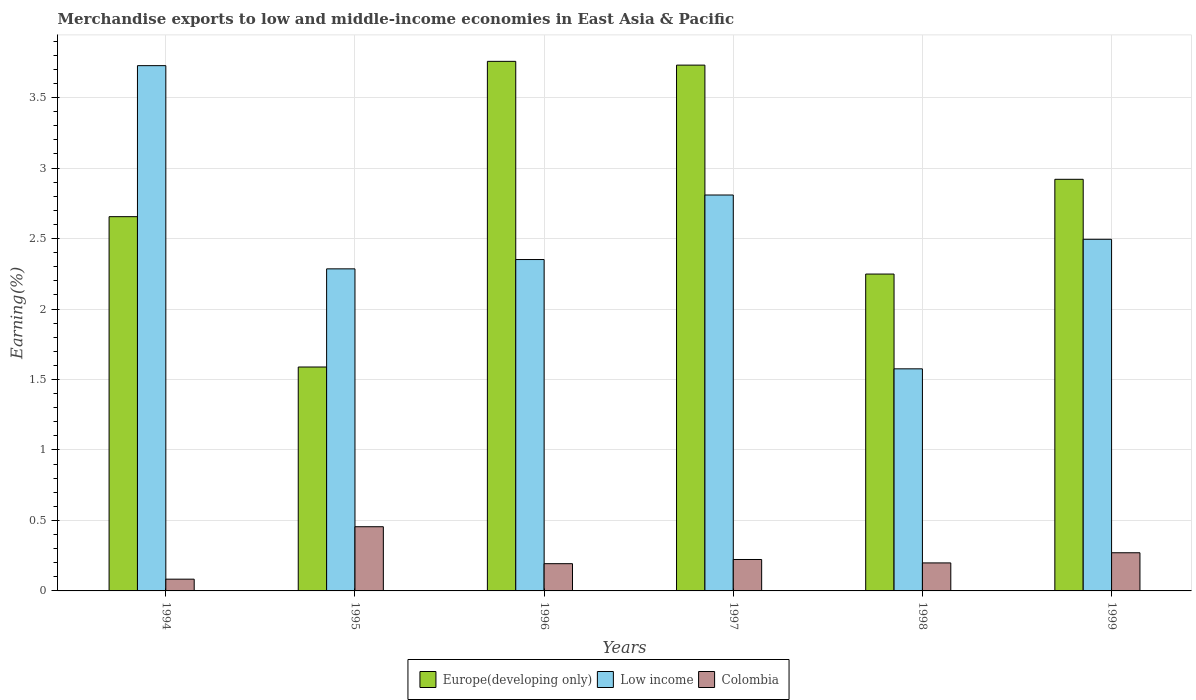How many groups of bars are there?
Give a very brief answer. 6. Are the number of bars on each tick of the X-axis equal?
Provide a short and direct response. Yes. How many bars are there on the 6th tick from the left?
Offer a terse response. 3. What is the label of the 4th group of bars from the left?
Keep it short and to the point. 1997. What is the percentage of amount earned from merchandise exports in Low income in 1994?
Provide a short and direct response. 3.73. Across all years, what is the maximum percentage of amount earned from merchandise exports in Low income?
Your answer should be compact. 3.73. Across all years, what is the minimum percentage of amount earned from merchandise exports in Europe(developing only)?
Make the answer very short. 1.59. In which year was the percentage of amount earned from merchandise exports in Colombia minimum?
Your answer should be very brief. 1994. What is the total percentage of amount earned from merchandise exports in Europe(developing only) in the graph?
Give a very brief answer. 16.9. What is the difference between the percentage of amount earned from merchandise exports in Europe(developing only) in 1997 and that in 1999?
Your answer should be compact. 0.81. What is the difference between the percentage of amount earned from merchandise exports in Low income in 1994 and the percentage of amount earned from merchandise exports in Europe(developing only) in 1995?
Keep it short and to the point. 2.14. What is the average percentage of amount earned from merchandise exports in Low income per year?
Your answer should be very brief. 2.54. In the year 1995, what is the difference between the percentage of amount earned from merchandise exports in Low income and percentage of amount earned from merchandise exports in Europe(developing only)?
Your answer should be very brief. 0.7. In how many years, is the percentage of amount earned from merchandise exports in Low income greater than 1.8 %?
Keep it short and to the point. 5. What is the ratio of the percentage of amount earned from merchandise exports in Europe(developing only) in 1995 to that in 1999?
Offer a very short reply. 0.54. Is the percentage of amount earned from merchandise exports in Colombia in 1998 less than that in 1999?
Give a very brief answer. Yes. What is the difference between the highest and the second highest percentage of amount earned from merchandise exports in Colombia?
Give a very brief answer. 0.18. What is the difference between the highest and the lowest percentage of amount earned from merchandise exports in Europe(developing only)?
Provide a short and direct response. 2.17. Is the sum of the percentage of amount earned from merchandise exports in Colombia in 1994 and 1999 greater than the maximum percentage of amount earned from merchandise exports in Europe(developing only) across all years?
Keep it short and to the point. No. What does the 2nd bar from the right in 1998 represents?
Make the answer very short. Low income. Is it the case that in every year, the sum of the percentage of amount earned from merchandise exports in Colombia and percentage of amount earned from merchandise exports in Low income is greater than the percentage of amount earned from merchandise exports in Europe(developing only)?
Offer a very short reply. No. How many bars are there?
Offer a very short reply. 18. Are all the bars in the graph horizontal?
Provide a short and direct response. No. How many years are there in the graph?
Provide a short and direct response. 6. What is the difference between two consecutive major ticks on the Y-axis?
Keep it short and to the point. 0.5. Does the graph contain any zero values?
Your response must be concise. No. Does the graph contain grids?
Make the answer very short. Yes. Where does the legend appear in the graph?
Your answer should be very brief. Bottom center. How are the legend labels stacked?
Offer a very short reply. Horizontal. What is the title of the graph?
Make the answer very short. Merchandise exports to low and middle-income economies in East Asia & Pacific. Does "East Asia (all income levels)" appear as one of the legend labels in the graph?
Your response must be concise. No. What is the label or title of the X-axis?
Ensure brevity in your answer.  Years. What is the label or title of the Y-axis?
Provide a short and direct response. Earning(%). What is the Earning(%) in Europe(developing only) in 1994?
Keep it short and to the point. 2.66. What is the Earning(%) in Low income in 1994?
Give a very brief answer. 3.73. What is the Earning(%) of Colombia in 1994?
Your answer should be compact. 0.08. What is the Earning(%) in Europe(developing only) in 1995?
Your answer should be compact. 1.59. What is the Earning(%) of Low income in 1995?
Offer a very short reply. 2.29. What is the Earning(%) in Colombia in 1995?
Your response must be concise. 0.46. What is the Earning(%) in Europe(developing only) in 1996?
Offer a very short reply. 3.76. What is the Earning(%) in Low income in 1996?
Ensure brevity in your answer.  2.35. What is the Earning(%) in Colombia in 1996?
Your answer should be very brief. 0.19. What is the Earning(%) in Europe(developing only) in 1997?
Make the answer very short. 3.73. What is the Earning(%) in Low income in 1997?
Your response must be concise. 2.81. What is the Earning(%) in Colombia in 1997?
Provide a short and direct response. 0.22. What is the Earning(%) in Europe(developing only) in 1998?
Your response must be concise. 2.25. What is the Earning(%) in Low income in 1998?
Provide a short and direct response. 1.58. What is the Earning(%) in Colombia in 1998?
Provide a short and direct response. 0.2. What is the Earning(%) in Europe(developing only) in 1999?
Provide a short and direct response. 2.92. What is the Earning(%) of Low income in 1999?
Provide a short and direct response. 2.49. What is the Earning(%) in Colombia in 1999?
Provide a succinct answer. 0.27. Across all years, what is the maximum Earning(%) of Europe(developing only)?
Offer a very short reply. 3.76. Across all years, what is the maximum Earning(%) of Low income?
Your response must be concise. 3.73. Across all years, what is the maximum Earning(%) in Colombia?
Give a very brief answer. 0.46. Across all years, what is the minimum Earning(%) in Europe(developing only)?
Make the answer very short. 1.59. Across all years, what is the minimum Earning(%) in Low income?
Your response must be concise. 1.58. Across all years, what is the minimum Earning(%) of Colombia?
Keep it short and to the point. 0.08. What is the total Earning(%) of Europe(developing only) in the graph?
Your answer should be compact. 16.9. What is the total Earning(%) in Low income in the graph?
Provide a short and direct response. 15.24. What is the total Earning(%) in Colombia in the graph?
Offer a very short reply. 1.42. What is the difference between the Earning(%) in Europe(developing only) in 1994 and that in 1995?
Your answer should be very brief. 1.07. What is the difference between the Earning(%) in Low income in 1994 and that in 1995?
Make the answer very short. 1.44. What is the difference between the Earning(%) in Colombia in 1994 and that in 1995?
Provide a short and direct response. -0.37. What is the difference between the Earning(%) in Europe(developing only) in 1994 and that in 1996?
Ensure brevity in your answer.  -1.1. What is the difference between the Earning(%) in Low income in 1994 and that in 1996?
Provide a short and direct response. 1.38. What is the difference between the Earning(%) of Colombia in 1994 and that in 1996?
Keep it short and to the point. -0.11. What is the difference between the Earning(%) of Europe(developing only) in 1994 and that in 1997?
Your response must be concise. -1.08. What is the difference between the Earning(%) in Low income in 1994 and that in 1997?
Give a very brief answer. 0.92. What is the difference between the Earning(%) in Colombia in 1994 and that in 1997?
Your response must be concise. -0.14. What is the difference between the Earning(%) of Europe(developing only) in 1994 and that in 1998?
Your answer should be very brief. 0.41. What is the difference between the Earning(%) in Low income in 1994 and that in 1998?
Make the answer very short. 2.15. What is the difference between the Earning(%) of Colombia in 1994 and that in 1998?
Provide a succinct answer. -0.12. What is the difference between the Earning(%) of Europe(developing only) in 1994 and that in 1999?
Make the answer very short. -0.27. What is the difference between the Earning(%) in Low income in 1994 and that in 1999?
Your answer should be very brief. 1.23. What is the difference between the Earning(%) in Colombia in 1994 and that in 1999?
Offer a very short reply. -0.19. What is the difference between the Earning(%) in Europe(developing only) in 1995 and that in 1996?
Ensure brevity in your answer.  -2.17. What is the difference between the Earning(%) of Low income in 1995 and that in 1996?
Provide a short and direct response. -0.07. What is the difference between the Earning(%) in Colombia in 1995 and that in 1996?
Make the answer very short. 0.26. What is the difference between the Earning(%) of Europe(developing only) in 1995 and that in 1997?
Offer a very short reply. -2.14. What is the difference between the Earning(%) in Low income in 1995 and that in 1997?
Offer a very short reply. -0.52. What is the difference between the Earning(%) in Colombia in 1995 and that in 1997?
Ensure brevity in your answer.  0.23. What is the difference between the Earning(%) in Europe(developing only) in 1995 and that in 1998?
Your answer should be compact. -0.66. What is the difference between the Earning(%) of Low income in 1995 and that in 1998?
Your answer should be compact. 0.71. What is the difference between the Earning(%) in Colombia in 1995 and that in 1998?
Make the answer very short. 0.26. What is the difference between the Earning(%) of Europe(developing only) in 1995 and that in 1999?
Keep it short and to the point. -1.33. What is the difference between the Earning(%) in Low income in 1995 and that in 1999?
Offer a very short reply. -0.21. What is the difference between the Earning(%) in Colombia in 1995 and that in 1999?
Provide a succinct answer. 0.18. What is the difference between the Earning(%) of Europe(developing only) in 1996 and that in 1997?
Your answer should be very brief. 0.03. What is the difference between the Earning(%) of Low income in 1996 and that in 1997?
Offer a very short reply. -0.46. What is the difference between the Earning(%) in Colombia in 1996 and that in 1997?
Keep it short and to the point. -0.03. What is the difference between the Earning(%) of Europe(developing only) in 1996 and that in 1998?
Offer a very short reply. 1.51. What is the difference between the Earning(%) in Low income in 1996 and that in 1998?
Ensure brevity in your answer.  0.78. What is the difference between the Earning(%) of Colombia in 1996 and that in 1998?
Keep it short and to the point. -0.01. What is the difference between the Earning(%) of Europe(developing only) in 1996 and that in 1999?
Ensure brevity in your answer.  0.84. What is the difference between the Earning(%) of Low income in 1996 and that in 1999?
Provide a succinct answer. -0.14. What is the difference between the Earning(%) of Colombia in 1996 and that in 1999?
Keep it short and to the point. -0.08. What is the difference between the Earning(%) of Europe(developing only) in 1997 and that in 1998?
Offer a terse response. 1.48. What is the difference between the Earning(%) of Low income in 1997 and that in 1998?
Provide a short and direct response. 1.23. What is the difference between the Earning(%) in Colombia in 1997 and that in 1998?
Make the answer very short. 0.02. What is the difference between the Earning(%) of Europe(developing only) in 1997 and that in 1999?
Your response must be concise. 0.81. What is the difference between the Earning(%) of Low income in 1997 and that in 1999?
Your response must be concise. 0.31. What is the difference between the Earning(%) in Colombia in 1997 and that in 1999?
Give a very brief answer. -0.05. What is the difference between the Earning(%) of Europe(developing only) in 1998 and that in 1999?
Your response must be concise. -0.67. What is the difference between the Earning(%) in Low income in 1998 and that in 1999?
Offer a very short reply. -0.92. What is the difference between the Earning(%) of Colombia in 1998 and that in 1999?
Your response must be concise. -0.07. What is the difference between the Earning(%) in Europe(developing only) in 1994 and the Earning(%) in Low income in 1995?
Your answer should be compact. 0.37. What is the difference between the Earning(%) of Europe(developing only) in 1994 and the Earning(%) of Colombia in 1995?
Your answer should be compact. 2.2. What is the difference between the Earning(%) of Low income in 1994 and the Earning(%) of Colombia in 1995?
Give a very brief answer. 3.27. What is the difference between the Earning(%) of Europe(developing only) in 1994 and the Earning(%) of Low income in 1996?
Offer a very short reply. 0.3. What is the difference between the Earning(%) in Europe(developing only) in 1994 and the Earning(%) in Colombia in 1996?
Your answer should be very brief. 2.46. What is the difference between the Earning(%) in Low income in 1994 and the Earning(%) in Colombia in 1996?
Your response must be concise. 3.53. What is the difference between the Earning(%) in Europe(developing only) in 1994 and the Earning(%) in Low income in 1997?
Provide a short and direct response. -0.15. What is the difference between the Earning(%) of Europe(developing only) in 1994 and the Earning(%) of Colombia in 1997?
Offer a terse response. 2.43. What is the difference between the Earning(%) of Low income in 1994 and the Earning(%) of Colombia in 1997?
Keep it short and to the point. 3.5. What is the difference between the Earning(%) in Europe(developing only) in 1994 and the Earning(%) in Low income in 1998?
Ensure brevity in your answer.  1.08. What is the difference between the Earning(%) of Europe(developing only) in 1994 and the Earning(%) of Colombia in 1998?
Your answer should be compact. 2.46. What is the difference between the Earning(%) of Low income in 1994 and the Earning(%) of Colombia in 1998?
Provide a short and direct response. 3.53. What is the difference between the Earning(%) in Europe(developing only) in 1994 and the Earning(%) in Low income in 1999?
Ensure brevity in your answer.  0.16. What is the difference between the Earning(%) in Europe(developing only) in 1994 and the Earning(%) in Colombia in 1999?
Provide a succinct answer. 2.38. What is the difference between the Earning(%) of Low income in 1994 and the Earning(%) of Colombia in 1999?
Offer a terse response. 3.46. What is the difference between the Earning(%) of Europe(developing only) in 1995 and the Earning(%) of Low income in 1996?
Make the answer very short. -0.76. What is the difference between the Earning(%) of Europe(developing only) in 1995 and the Earning(%) of Colombia in 1996?
Make the answer very short. 1.4. What is the difference between the Earning(%) in Low income in 1995 and the Earning(%) in Colombia in 1996?
Give a very brief answer. 2.09. What is the difference between the Earning(%) in Europe(developing only) in 1995 and the Earning(%) in Low income in 1997?
Offer a terse response. -1.22. What is the difference between the Earning(%) of Europe(developing only) in 1995 and the Earning(%) of Colombia in 1997?
Your answer should be very brief. 1.37. What is the difference between the Earning(%) of Low income in 1995 and the Earning(%) of Colombia in 1997?
Provide a short and direct response. 2.06. What is the difference between the Earning(%) in Europe(developing only) in 1995 and the Earning(%) in Low income in 1998?
Give a very brief answer. 0.01. What is the difference between the Earning(%) of Europe(developing only) in 1995 and the Earning(%) of Colombia in 1998?
Your answer should be compact. 1.39. What is the difference between the Earning(%) of Low income in 1995 and the Earning(%) of Colombia in 1998?
Your response must be concise. 2.09. What is the difference between the Earning(%) in Europe(developing only) in 1995 and the Earning(%) in Low income in 1999?
Offer a terse response. -0.91. What is the difference between the Earning(%) of Europe(developing only) in 1995 and the Earning(%) of Colombia in 1999?
Offer a terse response. 1.32. What is the difference between the Earning(%) of Low income in 1995 and the Earning(%) of Colombia in 1999?
Give a very brief answer. 2.01. What is the difference between the Earning(%) of Europe(developing only) in 1996 and the Earning(%) of Low income in 1997?
Offer a terse response. 0.95. What is the difference between the Earning(%) of Europe(developing only) in 1996 and the Earning(%) of Colombia in 1997?
Give a very brief answer. 3.53. What is the difference between the Earning(%) of Low income in 1996 and the Earning(%) of Colombia in 1997?
Offer a terse response. 2.13. What is the difference between the Earning(%) in Europe(developing only) in 1996 and the Earning(%) in Low income in 1998?
Your answer should be very brief. 2.18. What is the difference between the Earning(%) of Europe(developing only) in 1996 and the Earning(%) of Colombia in 1998?
Your answer should be compact. 3.56. What is the difference between the Earning(%) of Low income in 1996 and the Earning(%) of Colombia in 1998?
Your response must be concise. 2.15. What is the difference between the Earning(%) of Europe(developing only) in 1996 and the Earning(%) of Low income in 1999?
Offer a very short reply. 1.26. What is the difference between the Earning(%) of Europe(developing only) in 1996 and the Earning(%) of Colombia in 1999?
Make the answer very short. 3.49. What is the difference between the Earning(%) of Low income in 1996 and the Earning(%) of Colombia in 1999?
Give a very brief answer. 2.08. What is the difference between the Earning(%) in Europe(developing only) in 1997 and the Earning(%) in Low income in 1998?
Make the answer very short. 2.15. What is the difference between the Earning(%) of Europe(developing only) in 1997 and the Earning(%) of Colombia in 1998?
Keep it short and to the point. 3.53. What is the difference between the Earning(%) in Low income in 1997 and the Earning(%) in Colombia in 1998?
Provide a short and direct response. 2.61. What is the difference between the Earning(%) in Europe(developing only) in 1997 and the Earning(%) in Low income in 1999?
Ensure brevity in your answer.  1.24. What is the difference between the Earning(%) in Europe(developing only) in 1997 and the Earning(%) in Colombia in 1999?
Ensure brevity in your answer.  3.46. What is the difference between the Earning(%) of Low income in 1997 and the Earning(%) of Colombia in 1999?
Make the answer very short. 2.54. What is the difference between the Earning(%) of Europe(developing only) in 1998 and the Earning(%) of Low income in 1999?
Your response must be concise. -0.25. What is the difference between the Earning(%) in Europe(developing only) in 1998 and the Earning(%) in Colombia in 1999?
Your response must be concise. 1.98. What is the difference between the Earning(%) in Low income in 1998 and the Earning(%) in Colombia in 1999?
Make the answer very short. 1.3. What is the average Earning(%) in Europe(developing only) per year?
Offer a very short reply. 2.82. What is the average Earning(%) of Low income per year?
Make the answer very short. 2.54. What is the average Earning(%) in Colombia per year?
Your answer should be very brief. 0.24. In the year 1994, what is the difference between the Earning(%) in Europe(developing only) and Earning(%) in Low income?
Keep it short and to the point. -1.07. In the year 1994, what is the difference between the Earning(%) of Europe(developing only) and Earning(%) of Colombia?
Your response must be concise. 2.57. In the year 1994, what is the difference between the Earning(%) in Low income and Earning(%) in Colombia?
Provide a short and direct response. 3.64. In the year 1995, what is the difference between the Earning(%) of Europe(developing only) and Earning(%) of Low income?
Keep it short and to the point. -0.7. In the year 1995, what is the difference between the Earning(%) in Europe(developing only) and Earning(%) in Colombia?
Keep it short and to the point. 1.13. In the year 1995, what is the difference between the Earning(%) of Low income and Earning(%) of Colombia?
Your answer should be compact. 1.83. In the year 1996, what is the difference between the Earning(%) of Europe(developing only) and Earning(%) of Low income?
Your answer should be very brief. 1.41. In the year 1996, what is the difference between the Earning(%) of Europe(developing only) and Earning(%) of Colombia?
Provide a succinct answer. 3.56. In the year 1996, what is the difference between the Earning(%) in Low income and Earning(%) in Colombia?
Keep it short and to the point. 2.16. In the year 1997, what is the difference between the Earning(%) of Europe(developing only) and Earning(%) of Low income?
Your response must be concise. 0.92. In the year 1997, what is the difference between the Earning(%) in Europe(developing only) and Earning(%) in Colombia?
Your answer should be compact. 3.51. In the year 1997, what is the difference between the Earning(%) in Low income and Earning(%) in Colombia?
Your response must be concise. 2.59. In the year 1998, what is the difference between the Earning(%) in Europe(developing only) and Earning(%) in Low income?
Make the answer very short. 0.67. In the year 1998, what is the difference between the Earning(%) in Europe(developing only) and Earning(%) in Colombia?
Provide a short and direct response. 2.05. In the year 1998, what is the difference between the Earning(%) in Low income and Earning(%) in Colombia?
Make the answer very short. 1.38. In the year 1999, what is the difference between the Earning(%) of Europe(developing only) and Earning(%) of Low income?
Give a very brief answer. 0.43. In the year 1999, what is the difference between the Earning(%) in Europe(developing only) and Earning(%) in Colombia?
Offer a very short reply. 2.65. In the year 1999, what is the difference between the Earning(%) of Low income and Earning(%) of Colombia?
Ensure brevity in your answer.  2.22. What is the ratio of the Earning(%) of Europe(developing only) in 1994 to that in 1995?
Provide a succinct answer. 1.67. What is the ratio of the Earning(%) in Low income in 1994 to that in 1995?
Provide a succinct answer. 1.63. What is the ratio of the Earning(%) in Colombia in 1994 to that in 1995?
Your answer should be very brief. 0.18. What is the ratio of the Earning(%) of Europe(developing only) in 1994 to that in 1996?
Keep it short and to the point. 0.71. What is the ratio of the Earning(%) in Low income in 1994 to that in 1996?
Provide a short and direct response. 1.59. What is the ratio of the Earning(%) of Colombia in 1994 to that in 1996?
Your answer should be compact. 0.43. What is the ratio of the Earning(%) in Europe(developing only) in 1994 to that in 1997?
Offer a terse response. 0.71. What is the ratio of the Earning(%) of Low income in 1994 to that in 1997?
Provide a succinct answer. 1.33. What is the ratio of the Earning(%) of Colombia in 1994 to that in 1997?
Provide a short and direct response. 0.37. What is the ratio of the Earning(%) in Europe(developing only) in 1994 to that in 1998?
Offer a very short reply. 1.18. What is the ratio of the Earning(%) of Low income in 1994 to that in 1998?
Make the answer very short. 2.37. What is the ratio of the Earning(%) in Colombia in 1994 to that in 1998?
Give a very brief answer. 0.42. What is the ratio of the Earning(%) in Europe(developing only) in 1994 to that in 1999?
Provide a succinct answer. 0.91. What is the ratio of the Earning(%) in Low income in 1994 to that in 1999?
Give a very brief answer. 1.49. What is the ratio of the Earning(%) of Colombia in 1994 to that in 1999?
Your response must be concise. 0.31. What is the ratio of the Earning(%) of Europe(developing only) in 1995 to that in 1996?
Your answer should be compact. 0.42. What is the ratio of the Earning(%) of Low income in 1995 to that in 1996?
Offer a terse response. 0.97. What is the ratio of the Earning(%) in Colombia in 1995 to that in 1996?
Provide a short and direct response. 2.36. What is the ratio of the Earning(%) in Europe(developing only) in 1995 to that in 1997?
Provide a succinct answer. 0.43. What is the ratio of the Earning(%) in Low income in 1995 to that in 1997?
Make the answer very short. 0.81. What is the ratio of the Earning(%) of Colombia in 1995 to that in 1997?
Offer a terse response. 2.04. What is the ratio of the Earning(%) of Europe(developing only) in 1995 to that in 1998?
Your answer should be compact. 0.71. What is the ratio of the Earning(%) in Low income in 1995 to that in 1998?
Provide a succinct answer. 1.45. What is the ratio of the Earning(%) in Colombia in 1995 to that in 1998?
Keep it short and to the point. 2.29. What is the ratio of the Earning(%) in Europe(developing only) in 1995 to that in 1999?
Your answer should be compact. 0.54. What is the ratio of the Earning(%) of Low income in 1995 to that in 1999?
Keep it short and to the point. 0.92. What is the ratio of the Earning(%) in Colombia in 1995 to that in 1999?
Ensure brevity in your answer.  1.68. What is the ratio of the Earning(%) of Europe(developing only) in 1996 to that in 1997?
Ensure brevity in your answer.  1.01. What is the ratio of the Earning(%) of Low income in 1996 to that in 1997?
Provide a short and direct response. 0.84. What is the ratio of the Earning(%) in Colombia in 1996 to that in 1997?
Ensure brevity in your answer.  0.87. What is the ratio of the Earning(%) of Europe(developing only) in 1996 to that in 1998?
Your answer should be compact. 1.67. What is the ratio of the Earning(%) in Low income in 1996 to that in 1998?
Your response must be concise. 1.49. What is the ratio of the Earning(%) of Colombia in 1996 to that in 1998?
Provide a short and direct response. 0.97. What is the ratio of the Earning(%) of Europe(developing only) in 1996 to that in 1999?
Ensure brevity in your answer.  1.29. What is the ratio of the Earning(%) of Low income in 1996 to that in 1999?
Keep it short and to the point. 0.94. What is the ratio of the Earning(%) of Colombia in 1996 to that in 1999?
Offer a very short reply. 0.71. What is the ratio of the Earning(%) in Europe(developing only) in 1997 to that in 1998?
Offer a very short reply. 1.66. What is the ratio of the Earning(%) in Low income in 1997 to that in 1998?
Make the answer very short. 1.78. What is the ratio of the Earning(%) in Colombia in 1997 to that in 1998?
Provide a succinct answer. 1.12. What is the ratio of the Earning(%) of Europe(developing only) in 1997 to that in 1999?
Make the answer very short. 1.28. What is the ratio of the Earning(%) in Low income in 1997 to that in 1999?
Keep it short and to the point. 1.13. What is the ratio of the Earning(%) in Colombia in 1997 to that in 1999?
Your response must be concise. 0.82. What is the ratio of the Earning(%) of Europe(developing only) in 1998 to that in 1999?
Give a very brief answer. 0.77. What is the ratio of the Earning(%) of Low income in 1998 to that in 1999?
Offer a very short reply. 0.63. What is the ratio of the Earning(%) of Colombia in 1998 to that in 1999?
Your answer should be very brief. 0.73. What is the difference between the highest and the second highest Earning(%) of Europe(developing only)?
Provide a succinct answer. 0.03. What is the difference between the highest and the second highest Earning(%) in Low income?
Provide a succinct answer. 0.92. What is the difference between the highest and the second highest Earning(%) of Colombia?
Your answer should be very brief. 0.18. What is the difference between the highest and the lowest Earning(%) of Europe(developing only)?
Your answer should be very brief. 2.17. What is the difference between the highest and the lowest Earning(%) in Low income?
Ensure brevity in your answer.  2.15. What is the difference between the highest and the lowest Earning(%) in Colombia?
Ensure brevity in your answer.  0.37. 